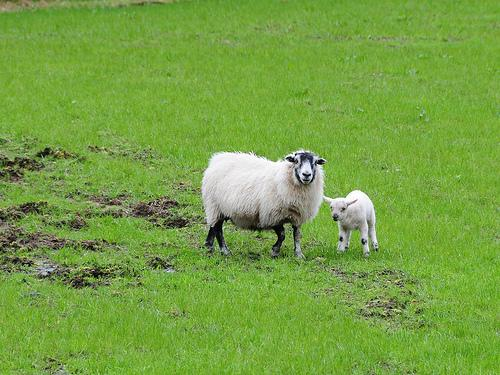Describe the color and size of the smallest patch of grass in the image. The smallest patch of green grass in the image has a width of 50 and a height of 50. Which object(s) appear to have the largest size on the image? The largest object in the image is the green grass for grazing with the size of 496 width and 496 height. What color is the mother sheep's face? The mother sheep's face is black and white. How many holes can be seen in the ground? There are six holes in the ground. Describe the overall scene depicted in the image. The image depicts a field with sheep and lambs grazing on the green grass, surrounded by patches of dirt, muddy areas, and holes in the ground. Write a brief story involving the mother sheep and her baby lamb. One sunny day, in a field full of green grass and patches of brown dirt, a mother sheep with a black and white face grazed peacefully with her baby lamb, who had a little black nose. The two explored the field together, avoiding the muddy areas and holes in the ground. Identify the main subject in the image and mention one interesting feature about them. The main subject in the image is a black and white sheep with its lamb; the sheep has grey hooves and the lamb has black patches on its legs. Count the total number of sheep and lambs in the image. There are 11 sheep and 3 lambs in the image. List two distinct features about the baby lamb and its mother. The baby lamb has a black nose and white ears, while the mother sheep has black ears and a black and white face. What type of animal can be seen grazing in the field? Sheep and lambs can be seen grazing in the field. 